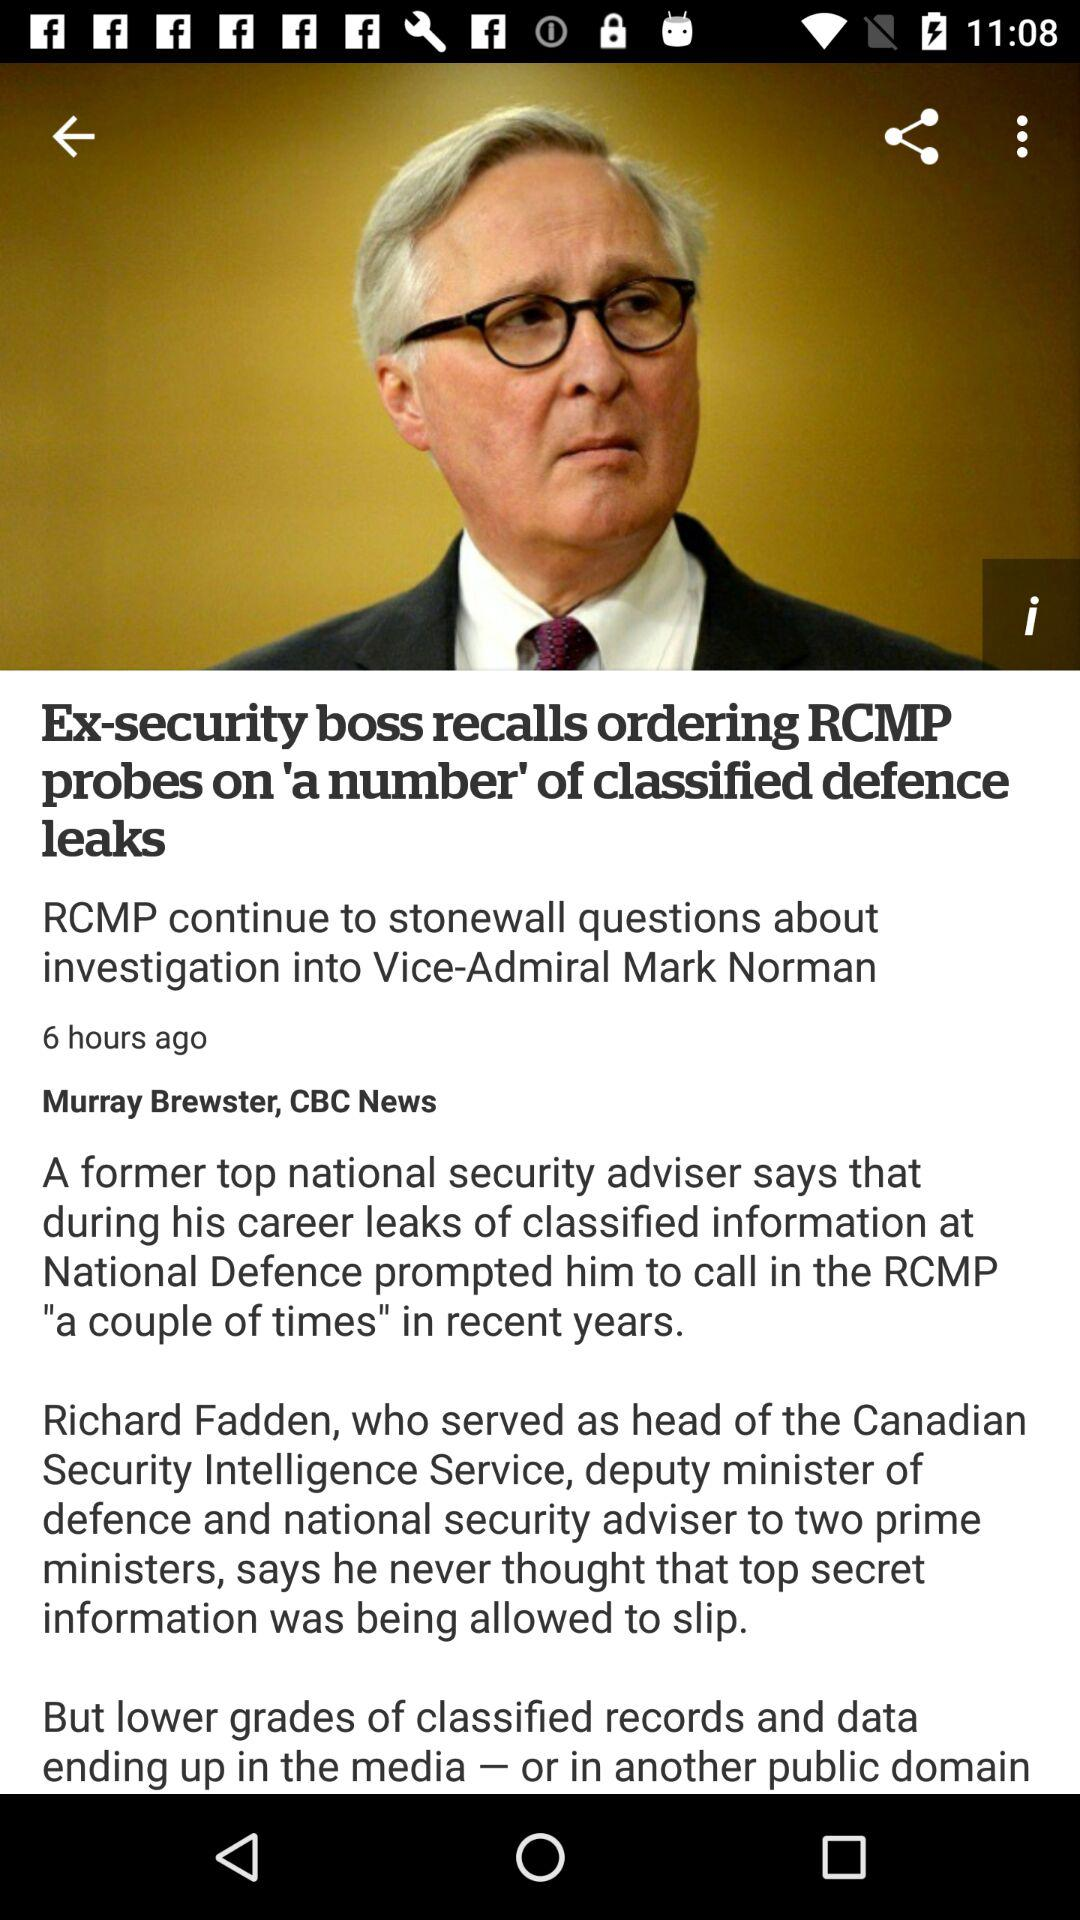Who is the journalist? The journalist is Murray Brewster. 